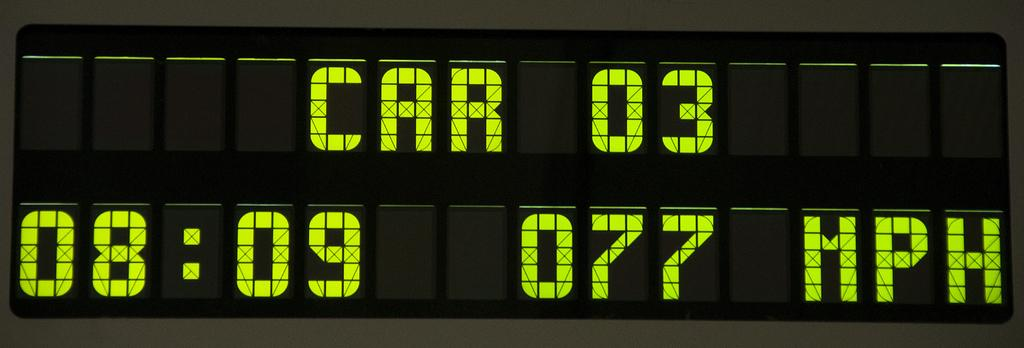Provide a one-sentence caption for the provided image. Black digital electronic display with green font reading CAR 03. 